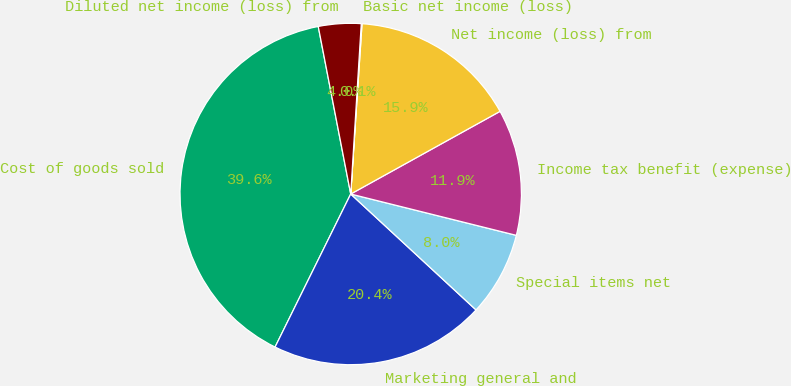Convert chart. <chart><loc_0><loc_0><loc_500><loc_500><pie_chart><fcel>Cost of goods sold<fcel>Marketing general and<fcel>Special items net<fcel>Income tax benefit (expense)<fcel>Net income (loss) from<fcel>Basic net income (loss)<fcel>Diluted net income (loss) from<nl><fcel>39.65%<fcel>20.43%<fcel>7.99%<fcel>11.94%<fcel>15.9%<fcel>0.07%<fcel>4.03%<nl></chart> 